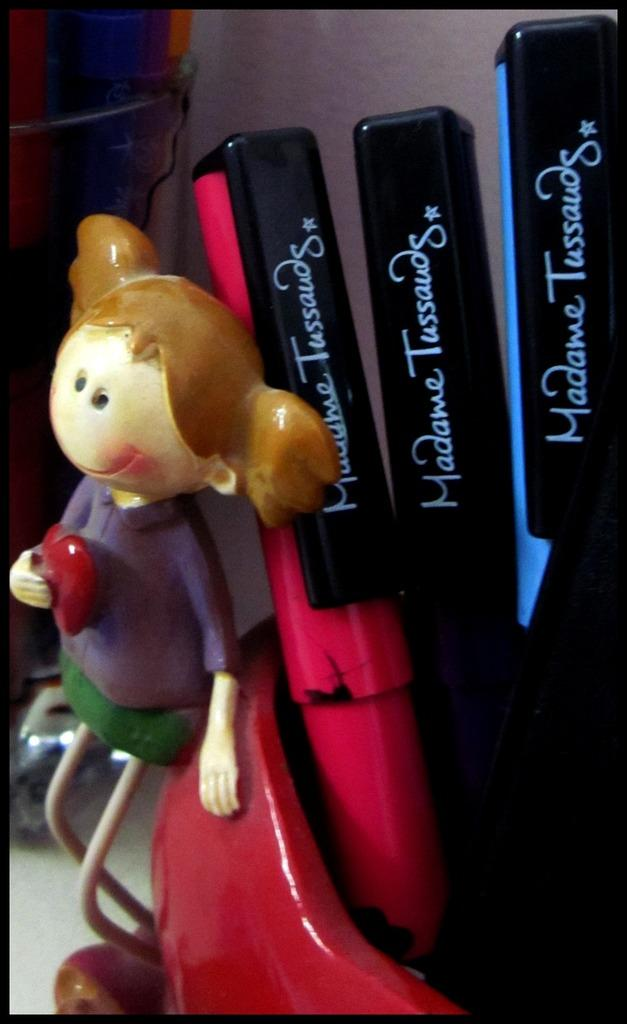<image>
Give a short and clear explanation of the subsequent image. Clay girl with a read heart sits on a red cup with Madame Tussauds markers. 